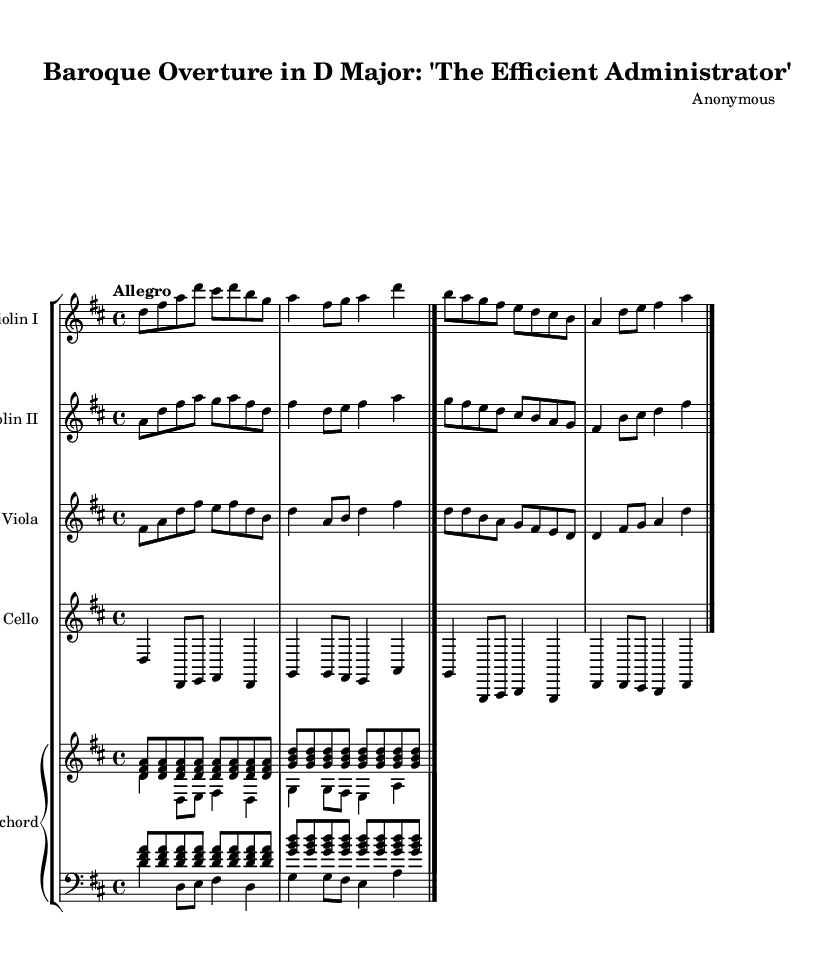What is the key signature of this music? The key signature indicates the key of D major, which has two sharps (F# and C#). This is typically seen at the beginning of the music sheet.
Answer: D major What is the time signature of this piece? The time signature is found at the beginning of the score, showing the organization of beats in each measure as 4 beats per measure. This is typically seen as a fraction-like symbol with a 4 over a 4.
Answer: 4/4 What is the tempo marking for this music? The tempo marking is given in the score, indicating speed. In this case, it specifies "Allegro," meaning a lively and fast tempo.
Answer: Allegro How many measures does the piece contain? By counting the individual segments separated by bar lines in the score, there are a total of 8 measures.
Answer: 8 Which instruments are included in this ensemble? The instruments listed in the score include Violin I, Violin II, Viola, Cello, and Harpsichord. This can be verified from the staff group names listed at the beginning of the music.
Answer: Violin I, Violin II, Viola, Cello, Harpsichord What is the rhythmic pattern of the harpsichord in the first few measures? In the first few measures, the harpsichord plays a repeating pattern of eighth notes followed by quarter notes, maintaining a lively accompaniment characteristic of Baroque music. This can be analyzed through the notes and their durations in the harpsichord's staff.
Answer: Eighth and quarter notes How does the character of this piece reflect Baroque styles? The piece exemplifies Baroque characteristics through its structured rhythm, ornamentation, and energetic motifs that are prevalent in overtures from that era. Analyzing the stylistic features in the score helps draw this conclusion.
Answer: Energetic motifs and structured rhythm 